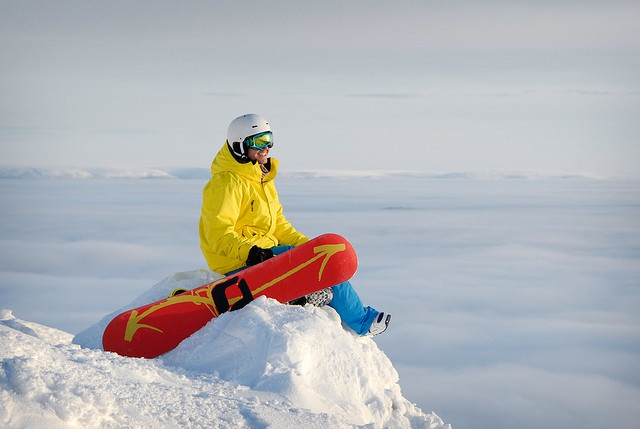Describe the objects in this image and their specific colors. I can see people in darkgray, olive, and gold tones and snowboard in darkgray, brown, maroon, and olive tones in this image. 